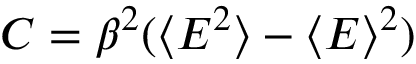<formula> <loc_0><loc_0><loc_500><loc_500>C = \beta ^ { 2 } ( \langle E ^ { 2 } \rangle - \langle E \rangle ^ { 2 } )</formula> 